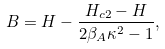Convert formula to latex. <formula><loc_0><loc_0><loc_500><loc_500>B = H - \frac { H _ { c 2 } - H } { 2 \beta _ { A } \kappa ^ { 2 } - 1 } ,</formula> 